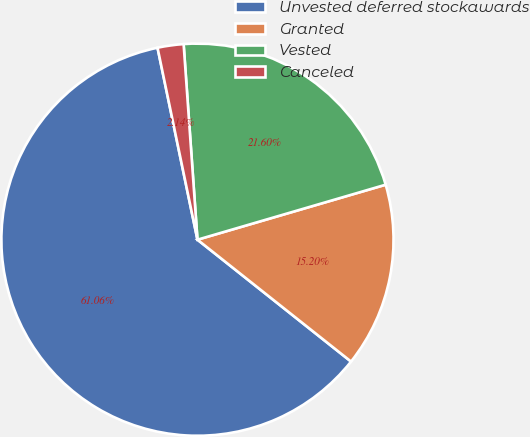Convert chart. <chart><loc_0><loc_0><loc_500><loc_500><pie_chart><fcel>Unvested deferred stockawards<fcel>Granted<fcel>Vested<fcel>Canceled<nl><fcel>61.06%<fcel>15.2%<fcel>21.6%<fcel>2.14%<nl></chart> 